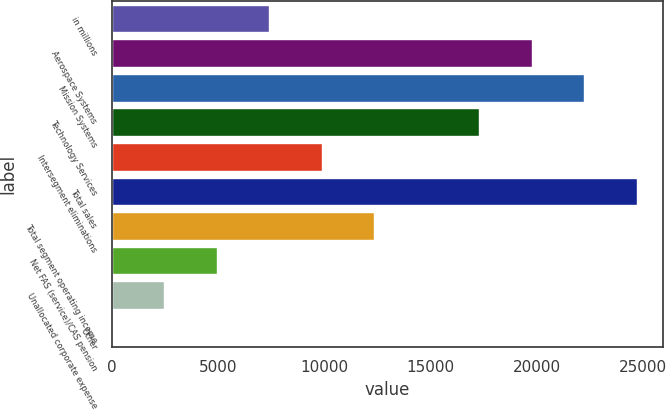Convert chart. <chart><loc_0><loc_0><loc_500><loc_500><bar_chart><fcel>in millions<fcel>Aerospace Systems<fcel>Mission Systems<fcel>Technology Services<fcel>Intersegment eliminations<fcel>Total sales<fcel>Total segment operating income<fcel>Net FAS (service)/CAS pension<fcel>Unallocated corporate expense<fcel>Other<nl><fcel>7415.3<fcel>19765.8<fcel>22235.9<fcel>17295.7<fcel>9885.4<fcel>24706<fcel>12355.5<fcel>4945.2<fcel>2475.1<fcel>5<nl></chart> 